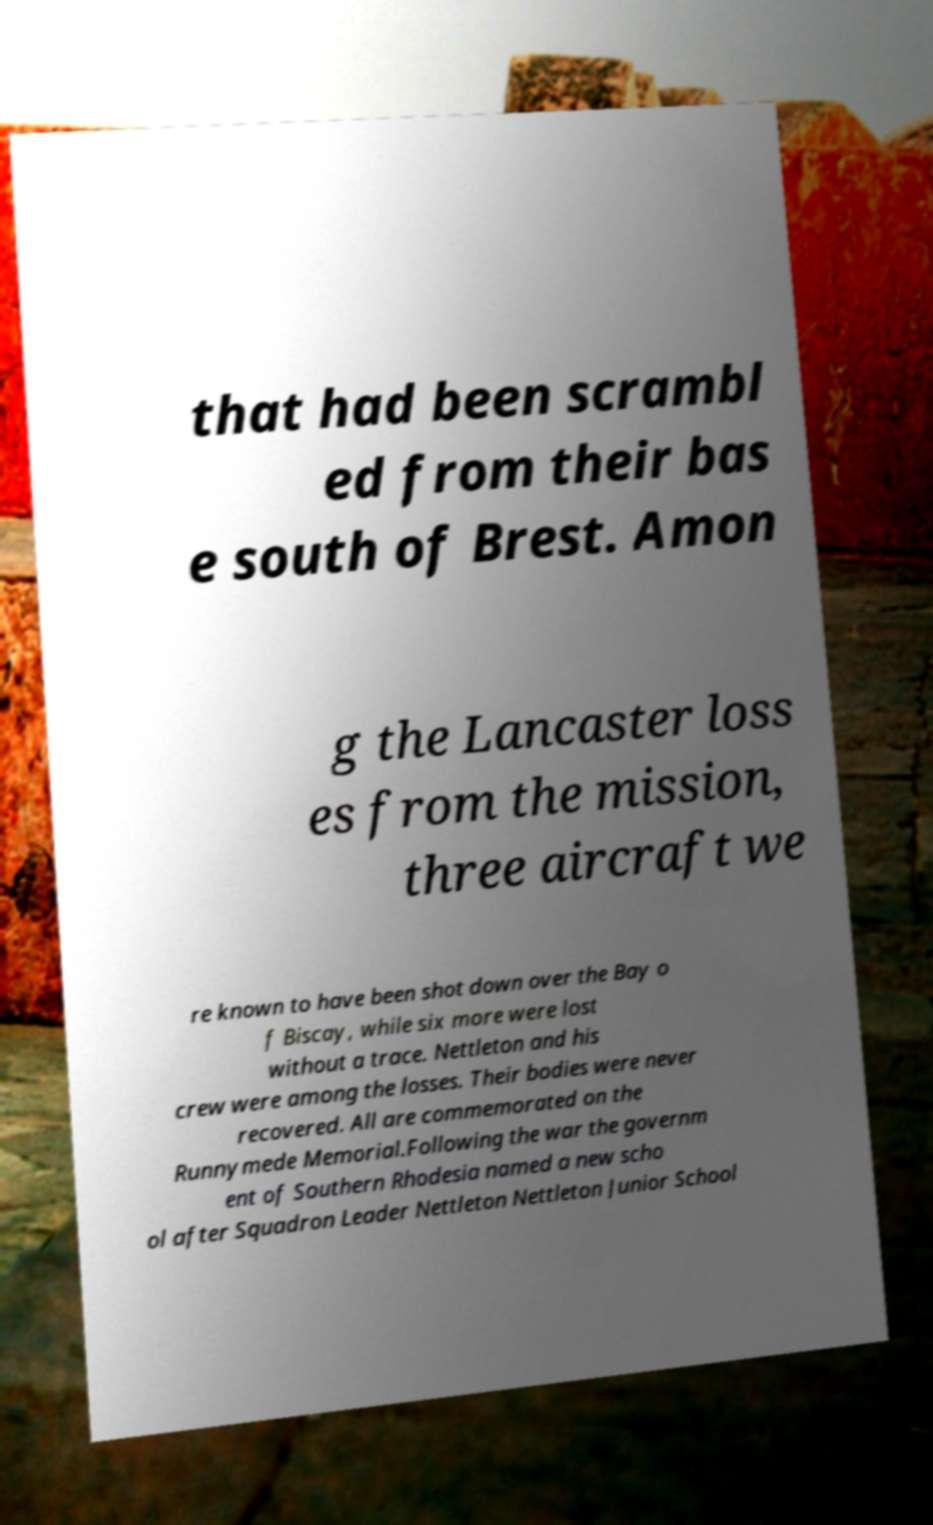Could you extract and type out the text from this image? that had been scrambl ed from their bas e south of Brest. Amon g the Lancaster loss es from the mission, three aircraft we re known to have been shot down over the Bay o f Biscay, while six more were lost without a trace. Nettleton and his crew were among the losses. Their bodies were never recovered. All are commemorated on the Runnymede Memorial.Following the war the governm ent of Southern Rhodesia named a new scho ol after Squadron Leader Nettleton Nettleton Junior School 